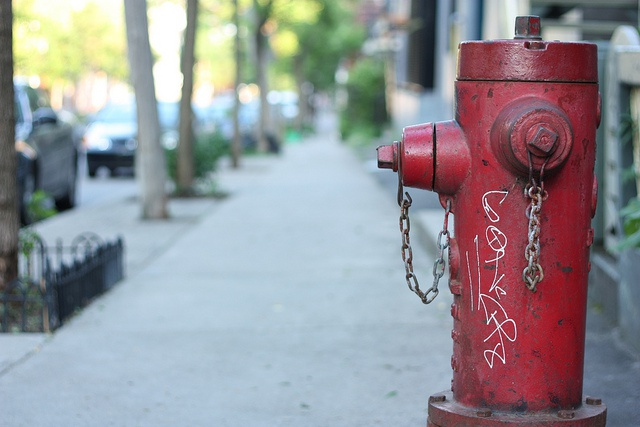Describe the objects in this image and their specific colors. I can see fire hydrant in gray, maroon, and brown tones, car in gray, black, and blue tones, car in gray, lightblue, teal, and darkgreen tones, and car in gray, lightblue, and black tones in this image. 